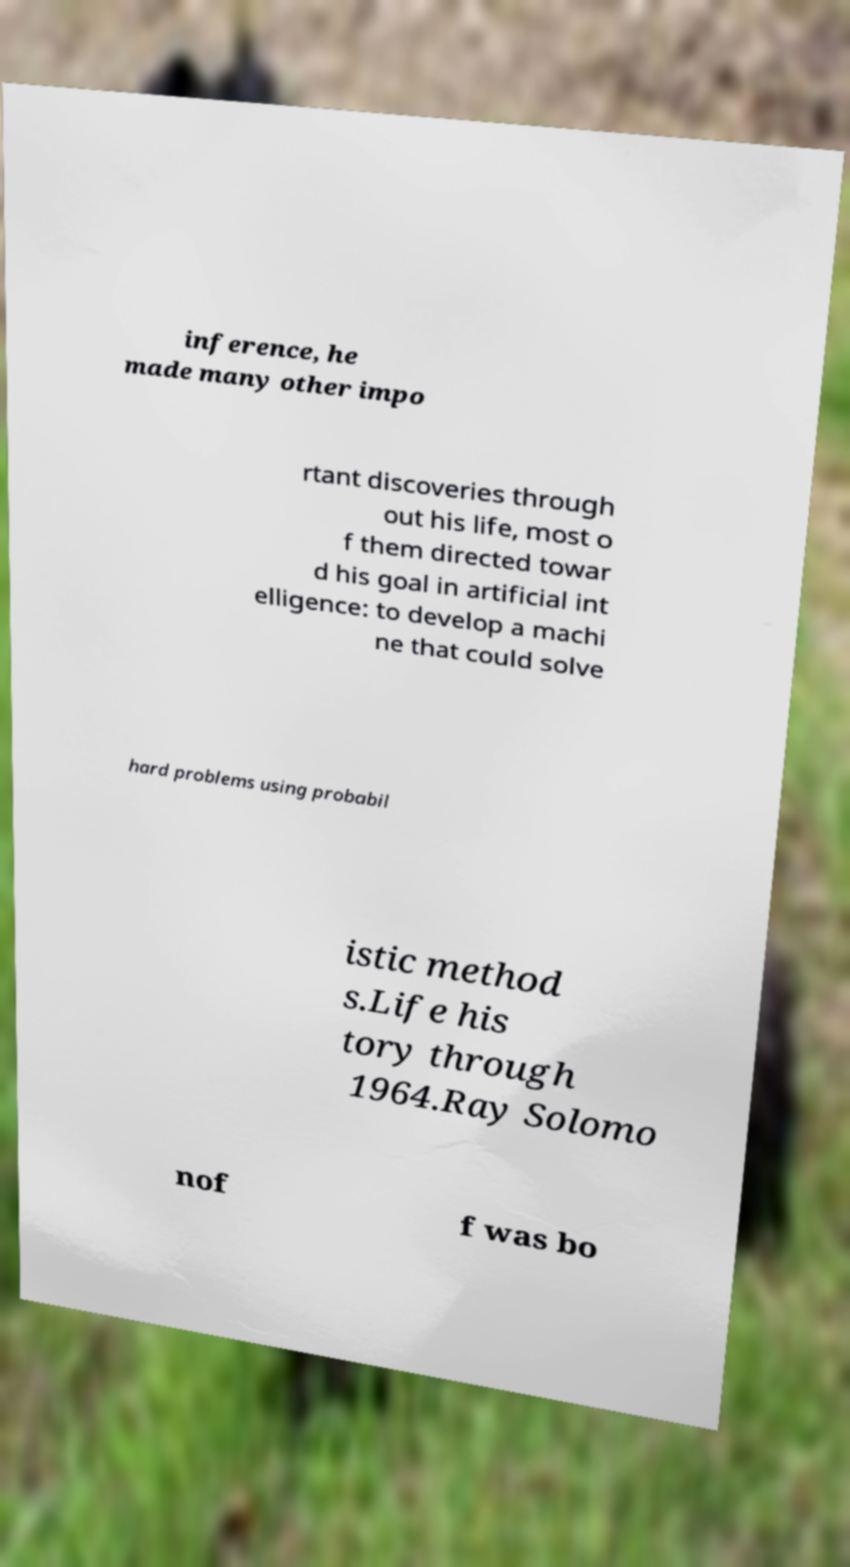I need the written content from this picture converted into text. Can you do that? inference, he made many other impo rtant discoveries through out his life, most o f them directed towar d his goal in artificial int elligence: to develop a machi ne that could solve hard problems using probabil istic method s.Life his tory through 1964.Ray Solomo nof f was bo 